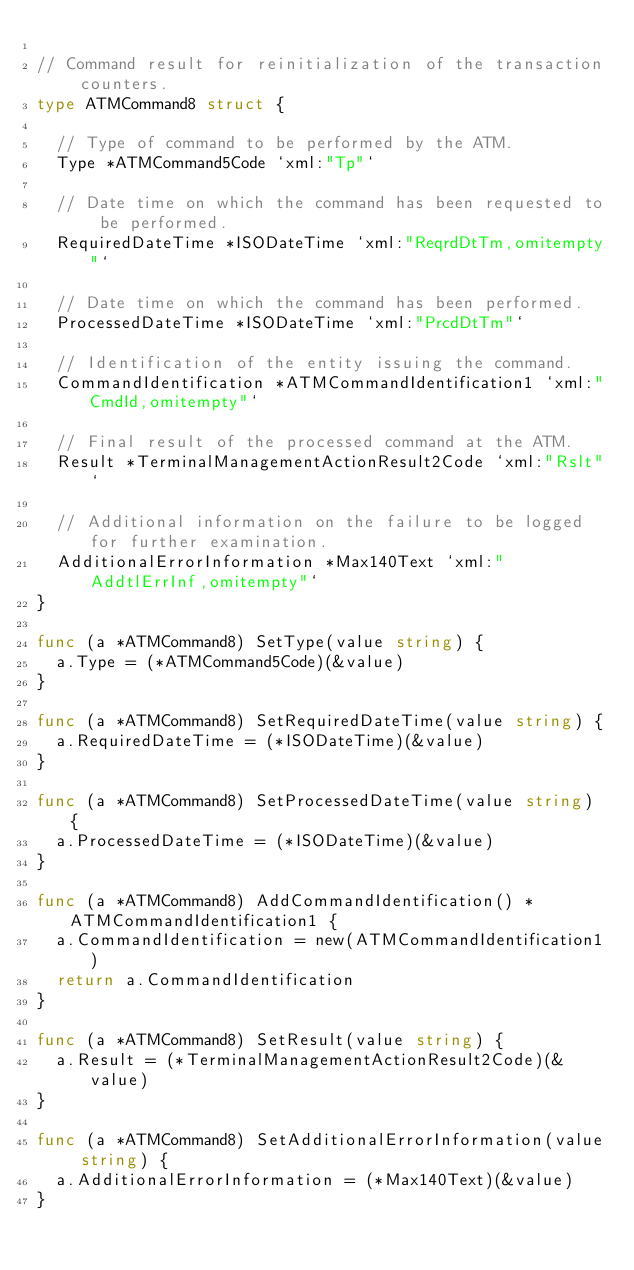Convert code to text. <code><loc_0><loc_0><loc_500><loc_500><_Go_>
// Command result for reinitialization of the transaction counters.
type ATMCommand8 struct {

	// Type of command to be performed by the ATM.
	Type *ATMCommand5Code `xml:"Tp"`

	// Date time on which the command has been requested to be performed.
	RequiredDateTime *ISODateTime `xml:"ReqrdDtTm,omitempty"`

	// Date time on which the command has been performed.
	ProcessedDateTime *ISODateTime `xml:"PrcdDtTm"`

	// Identification of the entity issuing the command.
	CommandIdentification *ATMCommandIdentification1 `xml:"CmdId,omitempty"`

	// Final result of the processed command at the ATM.
	Result *TerminalManagementActionResult2Code `xml:"Rslt"`

	// Additional information on the failure to be logged for further examination.
	AdditionalErrorInformation *Max140Text `xml:"AddtlErrInf,omitempty"`
}

func (a *ATMCommand8) SetType(value string) {
	a.Type = (*ATMCommand5Code)(&value)
}

func (a *ATMCommand8) SetRequiredDateTime(value string) {
	a.RequiredDateTime = (*ISODateTime)(&value)
}

func (a *ATMCommand8) SetProcessedDateTime(value string) {
	a.ProcessedDateTime = (*ISODateTime)(&value)
}

func (a *ATMCommand8) AddCommandIdentification() *ATMCommandIdentification1 {
	a.CommandIdentification = new(ATMCommandIdentification1)
	return a.CommandIdentification
}

func (a *ATMCommand8) SetResult(value string) {
	a.Result = (*TerminalManagementActionResult2Code)(&value)
}

func (a *ATMCommand8) SetAdditionalErrorInformation(value string) {
	a.AdditionalErrorInformation = (*Max140Text)(&value)
}
</code> 